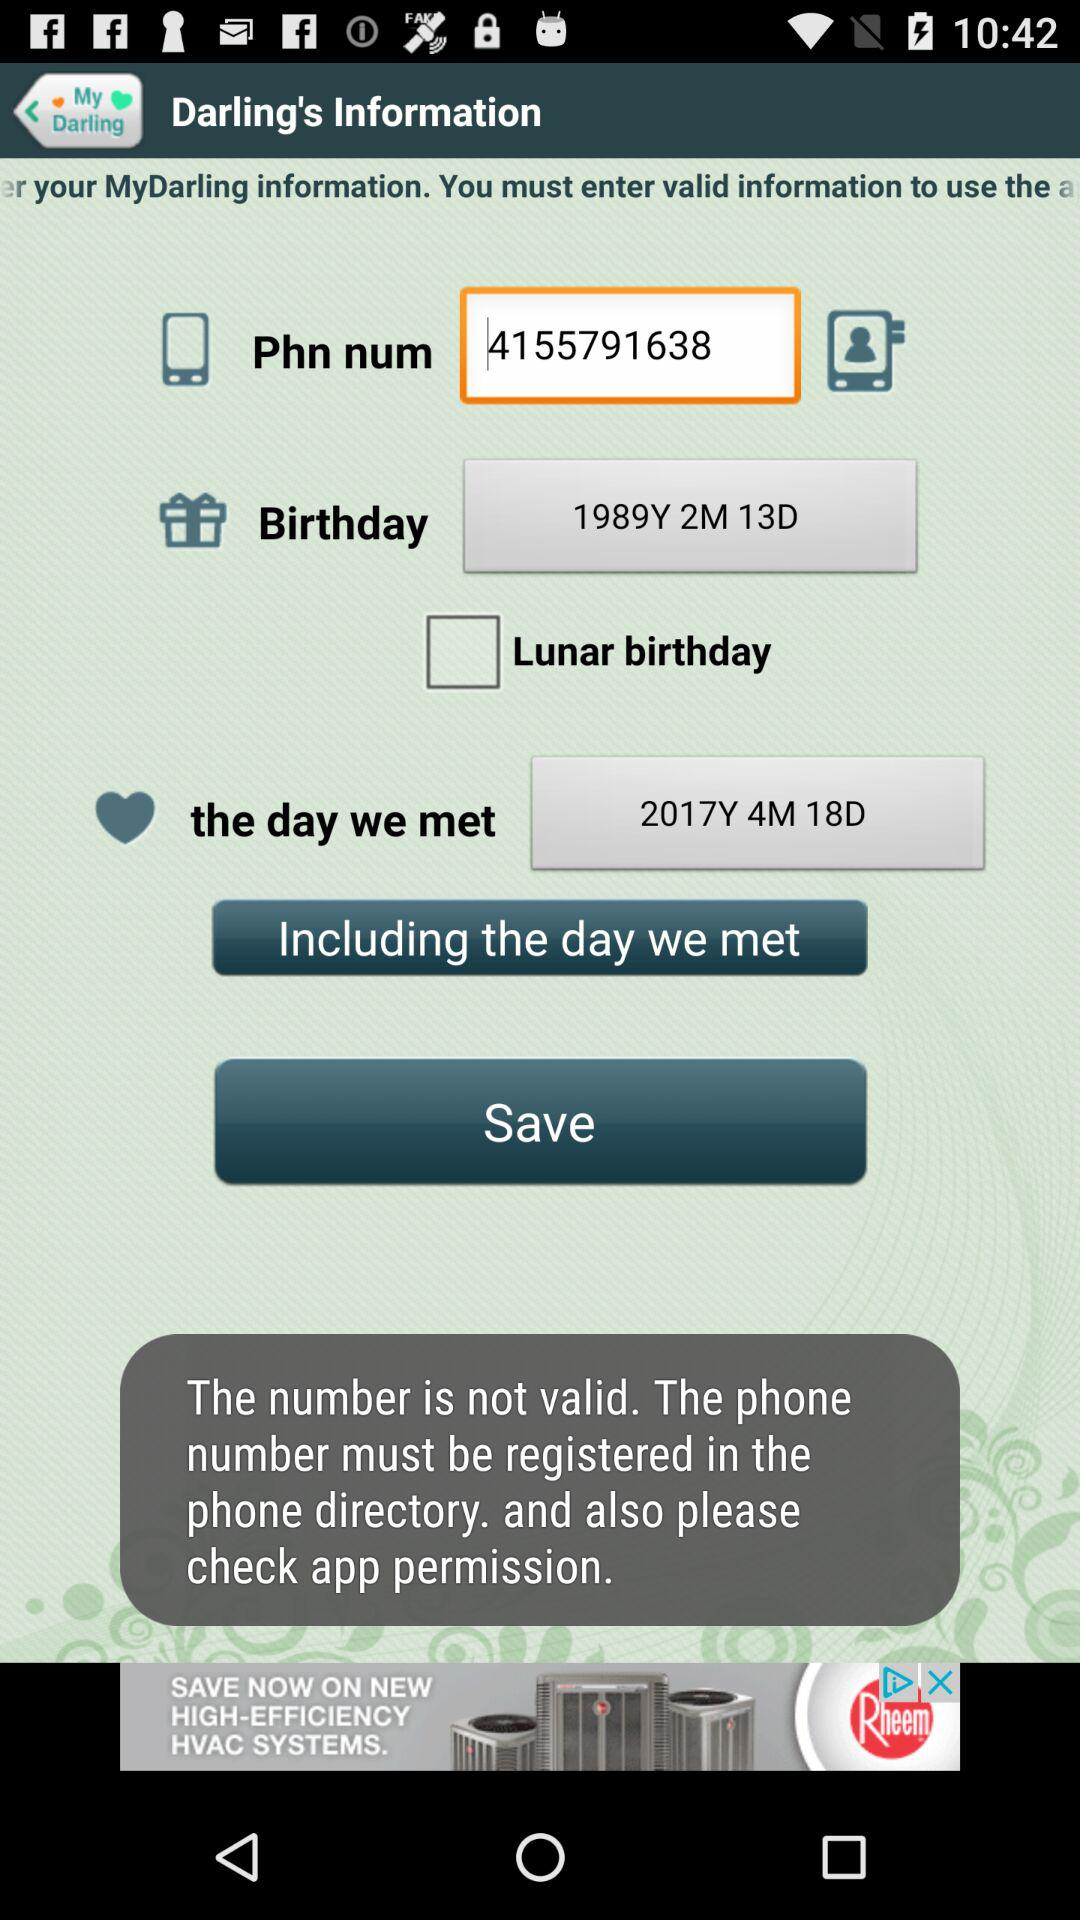What is the status of the lunar birthday? The status is off. 